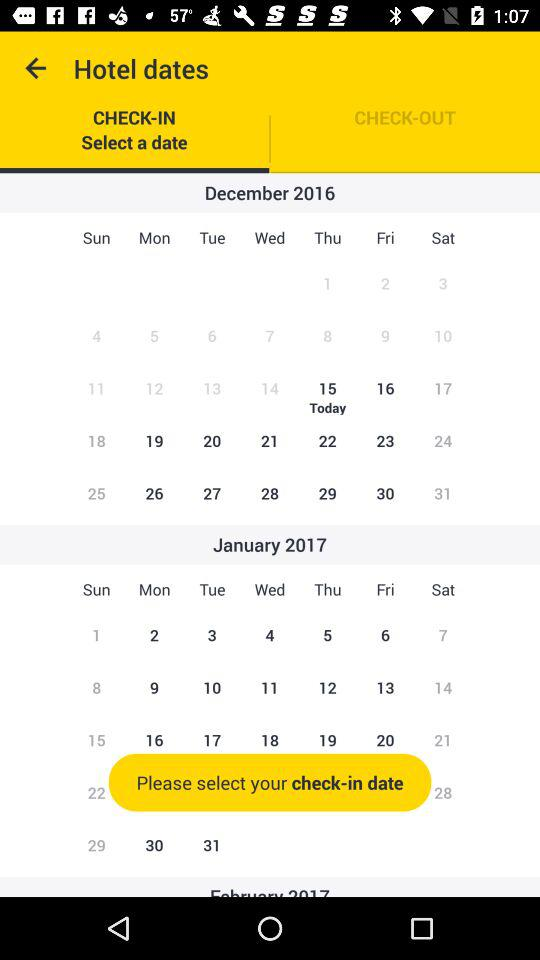Which tab is selected? The selected tab is "CHECK-IN". 